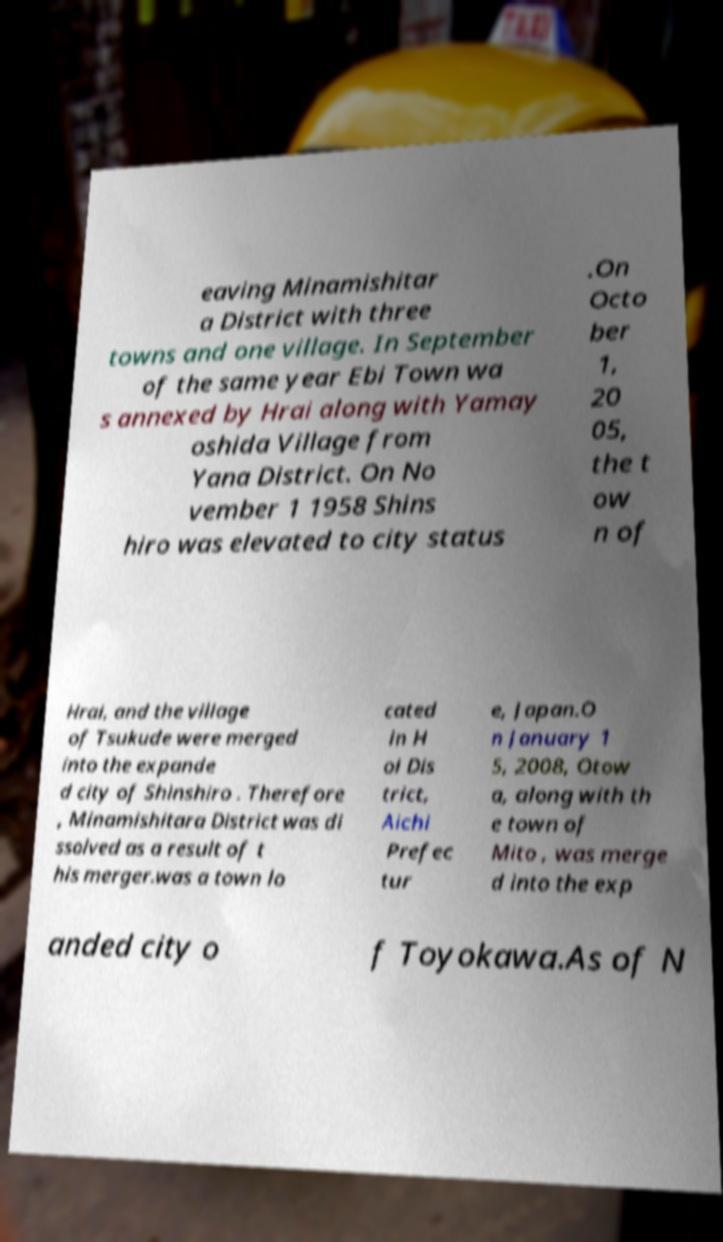For documentation purposes, I need the text within this image transcribed. Could you provide that? eaving Minamishitar a District with three towns and one village. In September of the same year Ebi Town wa s annexed by Hrai along with Yamay oshida Village from Yana District. On No vember 1 1958 Shins hiro was elevated to city status .On Octo ber 1, 20 05, the t ow n of Hrai, and the village of Tsukude were merged into the expande d city of Shinshiro . Therefore , Minamishitara District was di ssolved as a result of t his merger.was a town lo cated in H oi Dis trict, Aichi Prefec tur e, Japan.O n January 1 5, 2008, Otow a, along with th e town of Mito , was merge d into the exp anded city o f Toyokawa.As of N 